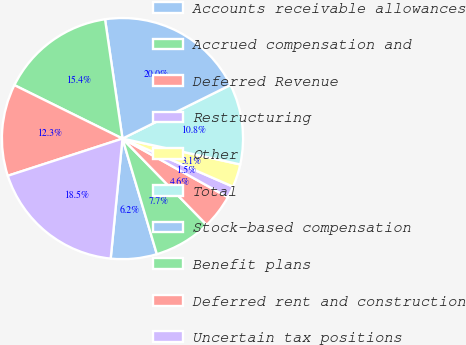Convert chart to OTSL. <chart><loc_0><loc_0><loc_500><loc_500><pie_chart><fcel>Accounts receivable allowances<fcel>Accrued compensation and<fcel>Deferred Revenue<fcel>Restructuring<fcel>Other<fcel>Total<fcel>Stock-based compensation<fcel>Benefit plans<fcel>Deferred rent and construction<fcel>Uncertain tax positions<nl><fcel>6.16%<fcel>7.7%<fcel>4.62%<fcel>1.55%<fcel>3.09%<fcel>10.77%<fcel>19.98%<fcel>15.38%<fcel>12.3%<fcel>18.45%<nl></chart> 